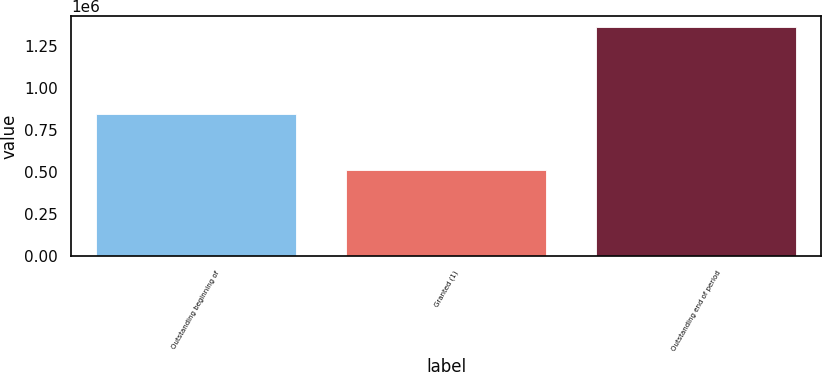Convert chart. <chart><loc_0><loc_0><loc_500><loc_500><bar_chart><fcel>Outstanding beginning of<fcel>Granted (1)<fcel>Outstanding end of period<nl><fcel>843793<fcel>513464<fcel>1.35726e+06<nl></chart> 